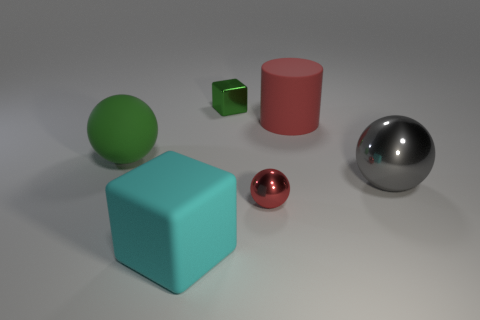Add 2 small yellow balls. How many objects exist? 8 Subtract all cylinders. How many objects are left? 5 Subtract all metallic cubes. Subtract all green matte objects. How many objects are left? 4 Add 2 gray balls. How many gray balls are left? 3 Add 2 shiny balls. How many shiny balls exist? 4 Subtract 0 purple cylinders. How many objects are left? 6 